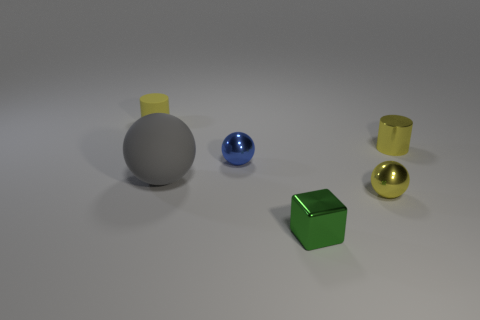Add 2 big objects. How many objects exist? 8 Subtract all cylinders. How many objects are left? 4 Subtract 0 brown cubes. How many objects are left? 6 Subtract all tiny green cubes. Subtract all big gray things. How many objects are left? 4 Add 5 tiny rubber cylinders. How many tiny rubber cylinders are left? 6 Add 3 small yellow blocks. How many small yellow blocks exist? 3 